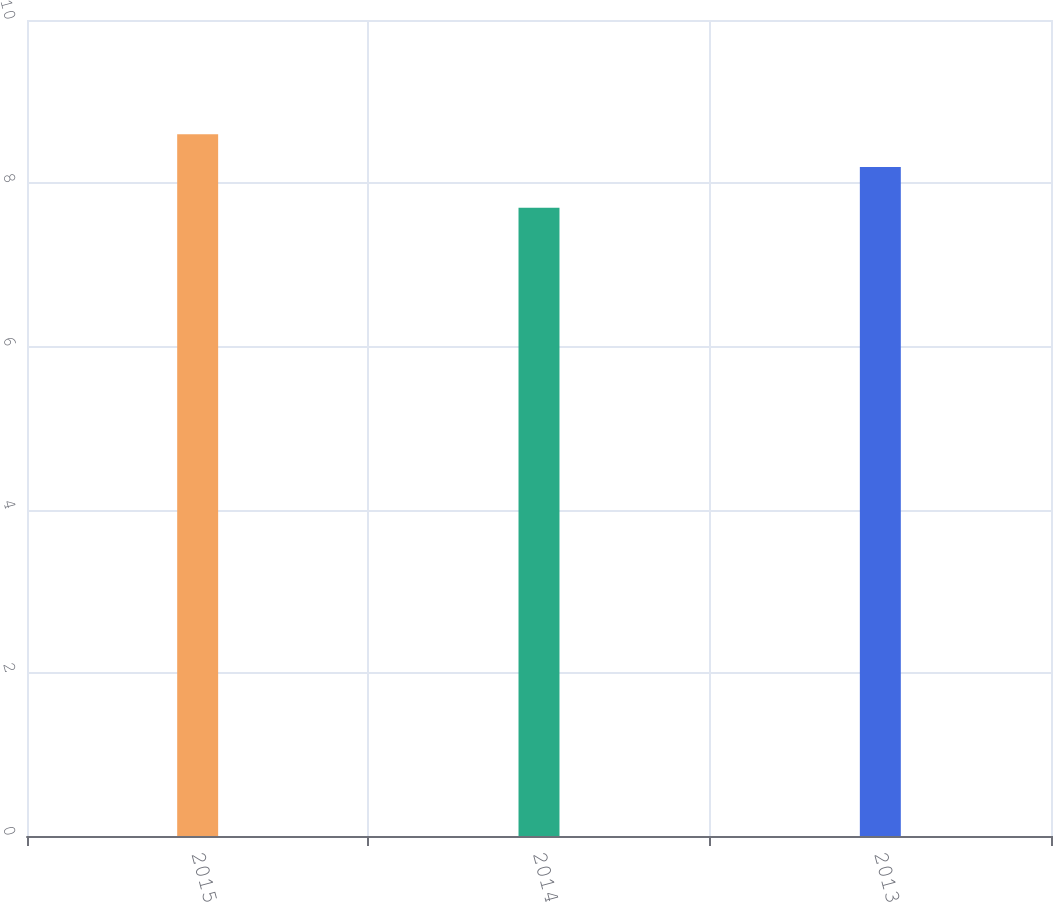<chart> <loc_0><loc_0><loc_500><loc_500><bar_chart><fcel>2015<fcel>2014<fcel>2013<nl><fcel>8.6<fcel>7.7<fcel>8.2<nl></chart> 